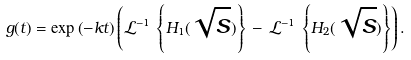Convert formula to latex. <formula><loc_0><loc_0><loc_500><loc_500>g ( t ) = \exp \left ( - k t \right ) \left ( \mathcal { L } ^ { - 1 } \, \left \{ H _ { 1 } ( \sqrt { s } ) \right \} \, - \, \mathcal { L } ^ { - 1 } \, \left \{ H _ { 2 } ( \sqrt { s } ) \right \} \right ) .</formula> 